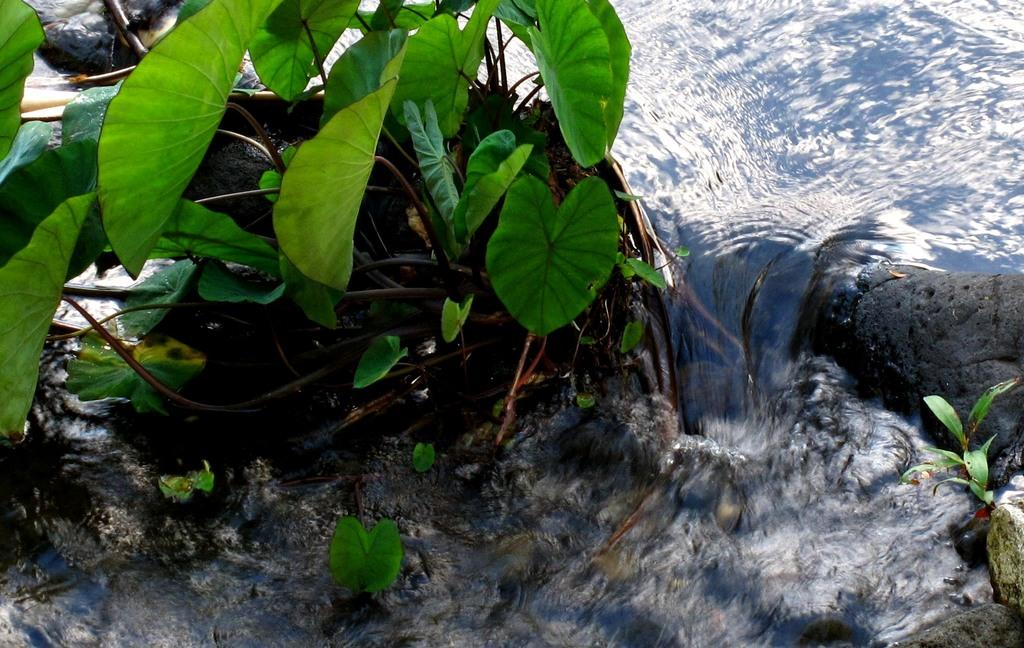What is happening in the image? There is water flowing in the image. What else can be seen in the image besides the water? There are plants present in the image. What is the aftermath of the hydrant in the image? There is no hydrant present in the image, so there is no aftermath to discuss. 